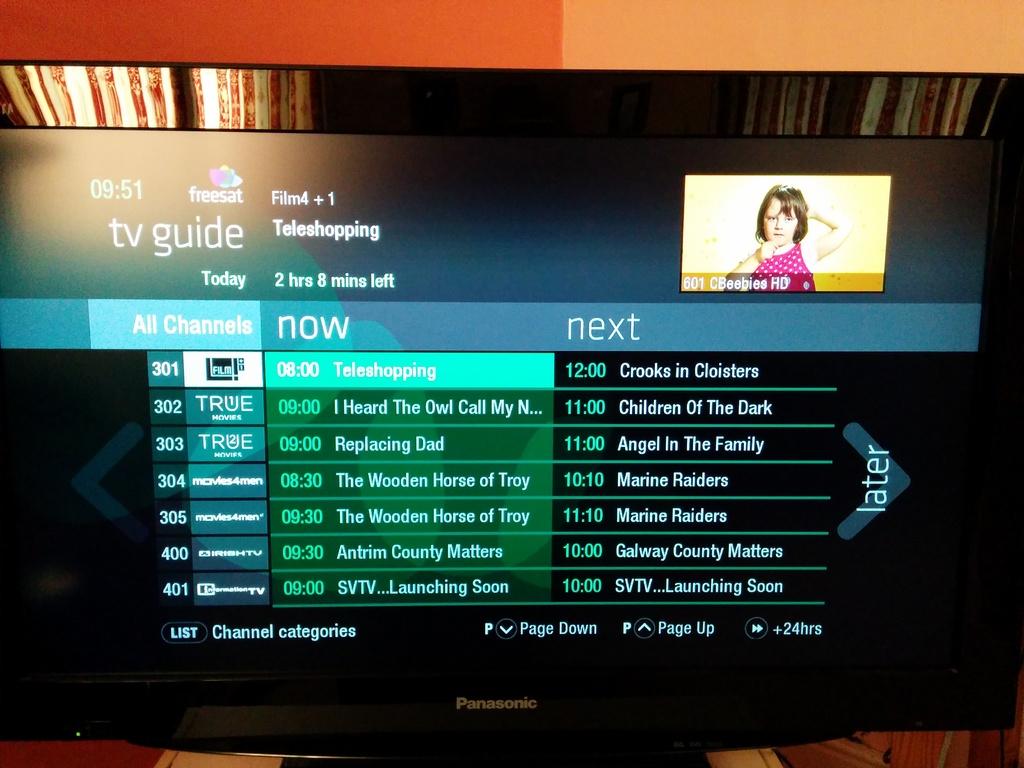Tv guide is good or bad?
Ensure brevity in your answer.  Answering does not require reading text in the image. 